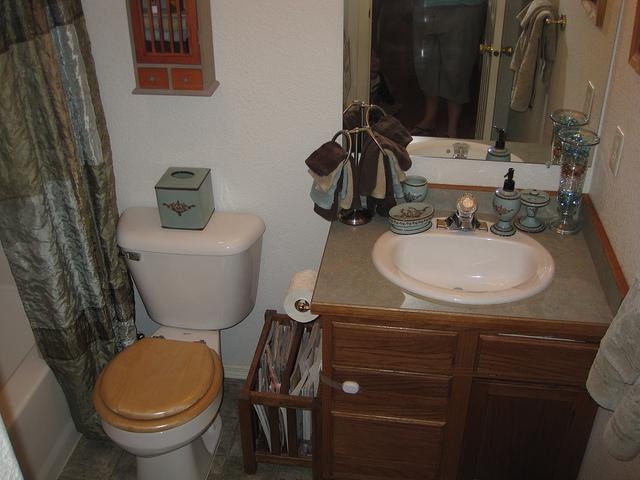What color is the tissue box on the top of the toilet bowl? blue 